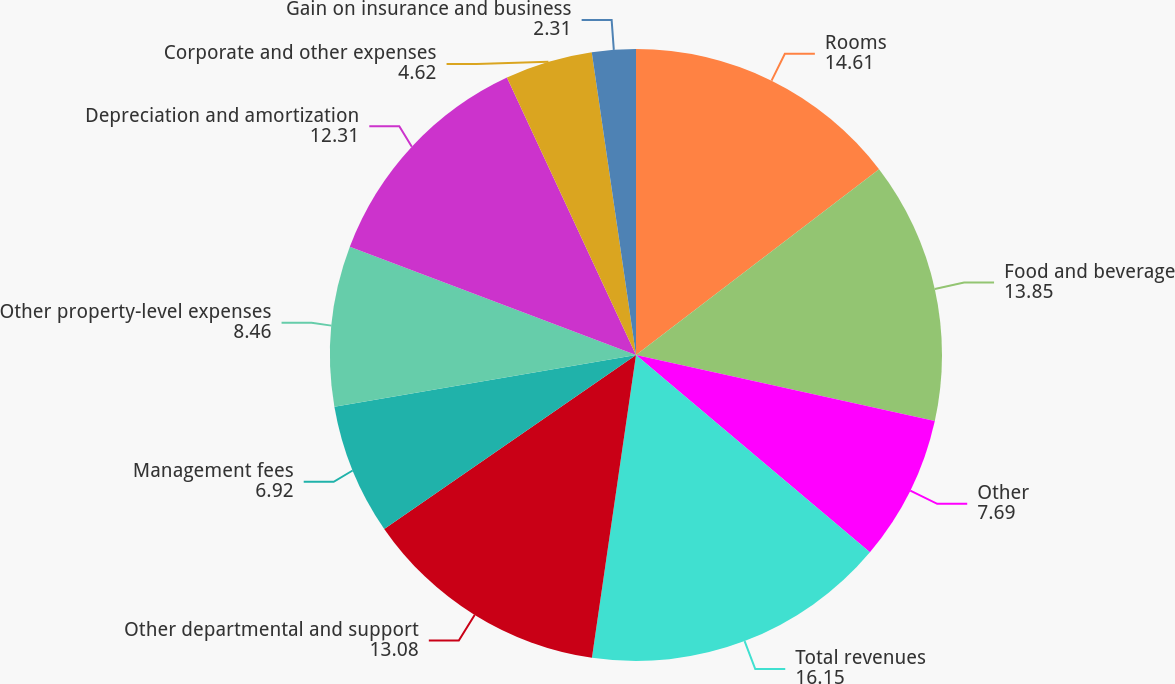Convert chart. <chart><loc_0><loc_0><loc_500><loc_500><pie_chart><fcel>Rooms<fcel>Food and beverage<fcel>Other<fcel>Total revenues<fcel>Other departmental and support<fcel>Management fees<fcel>Other property-level expenses<fcel>Depreciation and amortization<fcel>Corporate and other expenses<fcel>Gain on insurance and business<nl><fcel>14.61%<fcel>13.85%<fcel>7.69%<fcel>16.15%<fcel>13.08%<fcel>6.92%<fcel>8.46%<fcel>12.31%<fcel>4.62%<fcel>2.31%<nl></chart> 